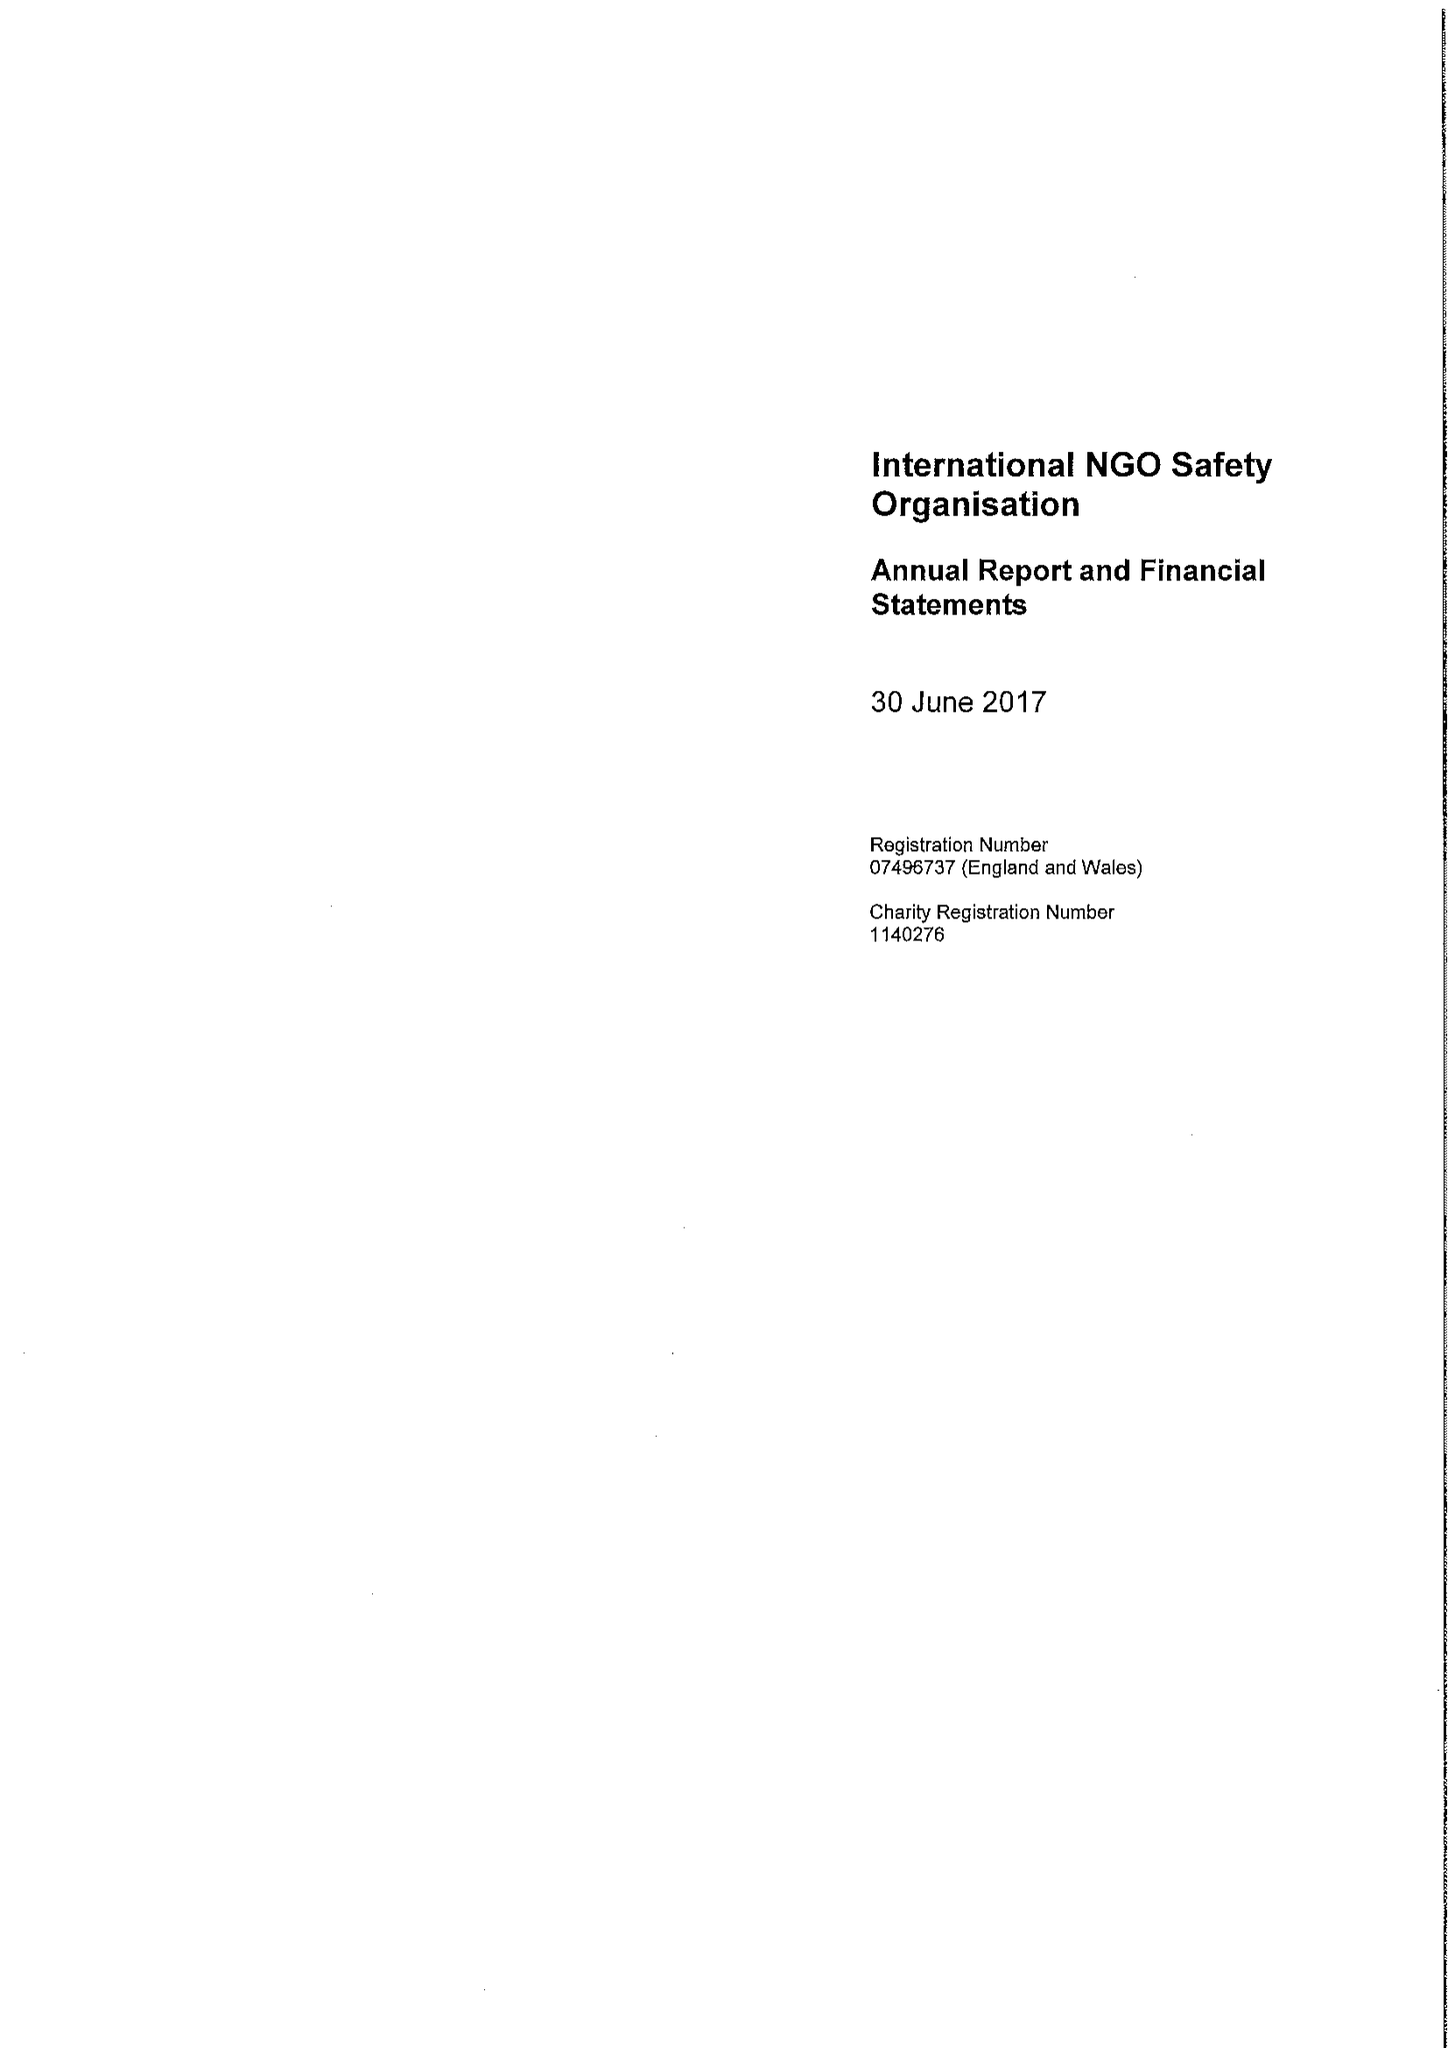What is the value for the spending_annually_in_british_pounds?
Answer the question using a single word or phrase. 12817048.00 